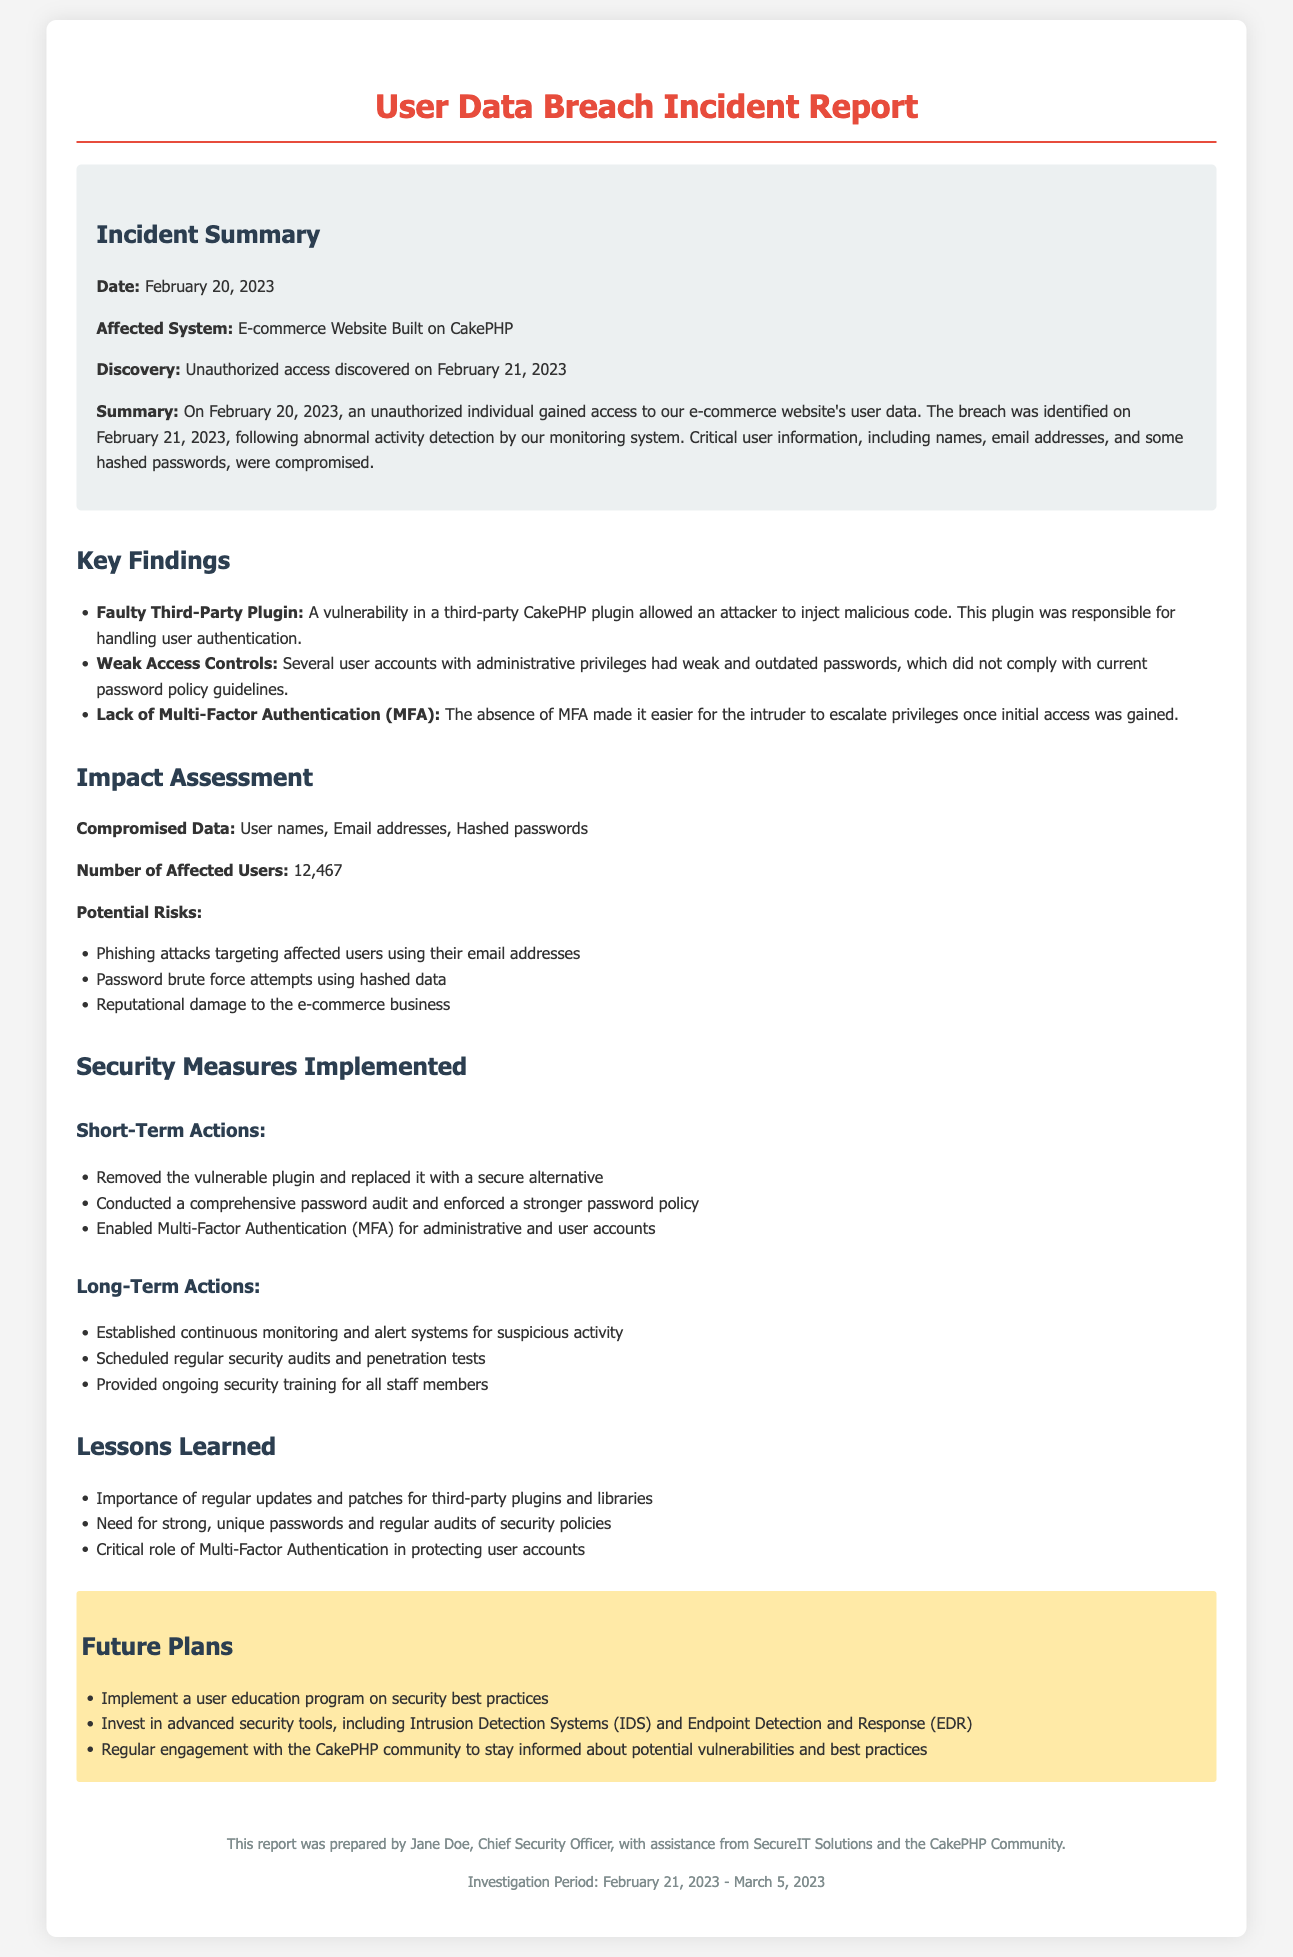What date was the incident discovered? The incident was discovered on February 21, 2023, following abnormal activity detection.
Answer: February 21, 2023 How many users were affected by the breach? The number of affected users is explicitly mentioned in the impact assessment section.
Answer: 12,467 What type of data was compromised during the breach? The types of compromised data include user names and email addresses, as specified in the impact section.
Answer: User names, email addresses, hashed passwords What security measure was implemented for all accounts? The report highlights that Multi-Factor Authentication was enabled for accounts as a security measure.
Answer: Multi-Factor Authentication (MFA) What was one of the key findings related to the plugin? The report cites a vulnerability in a third-party plugin responsible for user authentication as a key finding.
Answer: Vulnerability in a third-party CakePHP plugin What are the short-term actions taken after the incident? The report lists specific measures under "Short-Term Actions," including removing the vulnerable plugin.
Answer: Removed the vulnerable plugin and replaced it with a secure alternative What lesson was learned regarding passwords? The lessons section emphasizes the need for strong, unique passwords and regular audits.
Answer: Need for strong, unique passwords What is one of the future plans regarding user education? A plan for user education is mentioned in the future plans section of the report.
Answer: Implement a user education program on security best practices 